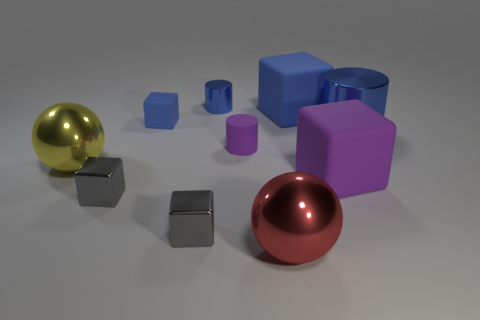What is the size of the ball on the right side of the yellow sphere?
Give a very brief answer. Large. Is there any other thing of the same color as the tiny matte cube?
Your response must be concise. Yes. Does the large ball on the left side of the tiny metal cylinder have the same material as the large red ball?
Provide a succinct answer. Yes. What number of big things are in front of the big cylinder and behind the big red metal thing?
Give a very brief answer. 2. What is the size of the blue block on the right side of the purple thing that is behind the purple block?
Offer a very short reply. Large. Is there any other thing that is made of the same material as the large red thing?
Your answer should be compact. Yes. Are there more big brown shiny cylinders than tiny purple objects?
Keep it short and to the point. No. There is a big matte block behind the big yellow metal thing; is its color the same as the big metallic ball in front of the large yellow metallic thing?
Offer a terse response. No. There is a blue block right of the red ball; are there any rubber objects in front of it?
Offer a terse response. Yes. Is the number of blue cylinders that are to the left of the purple block less than the number of large rubber cubes that are left of the small purple matte cylinder?
Make the answer very short. No. 